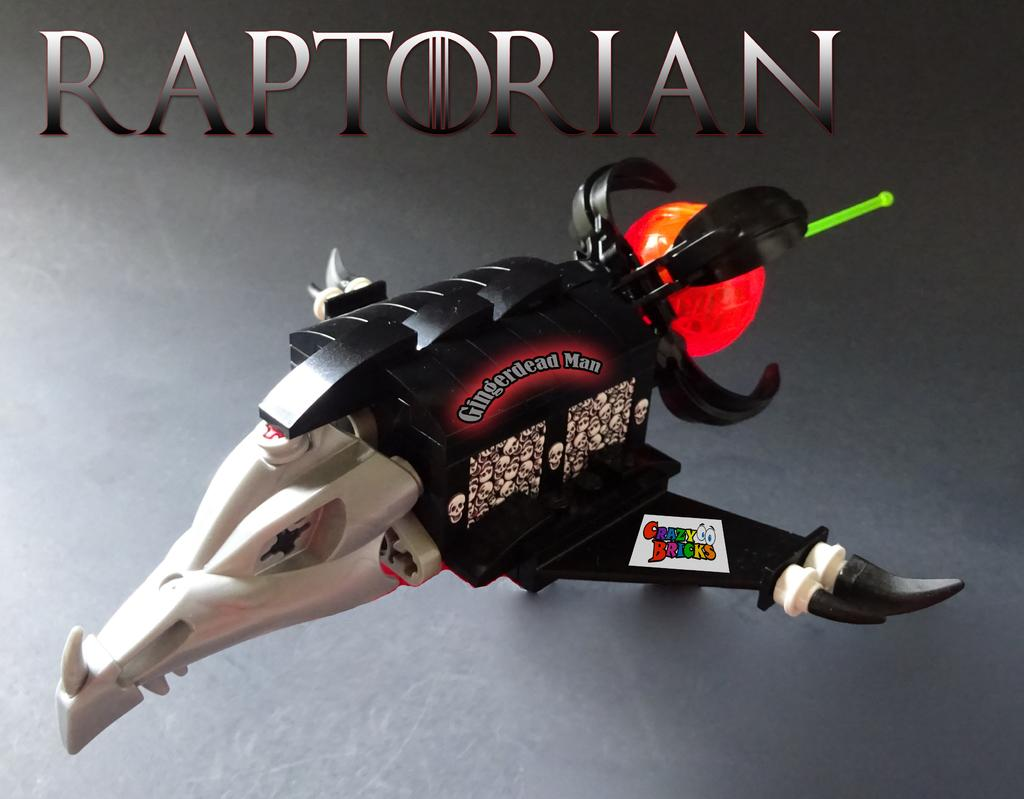What is featured in the image? There is a poster in the image. What is depicted on the poster? The poster contains a toy. How many geese are visible on the poster in the image? There are no geese visible on the poster in the image. What type of shoe is featured on the poster in the image? There is no shoe present on the poster in the image. 